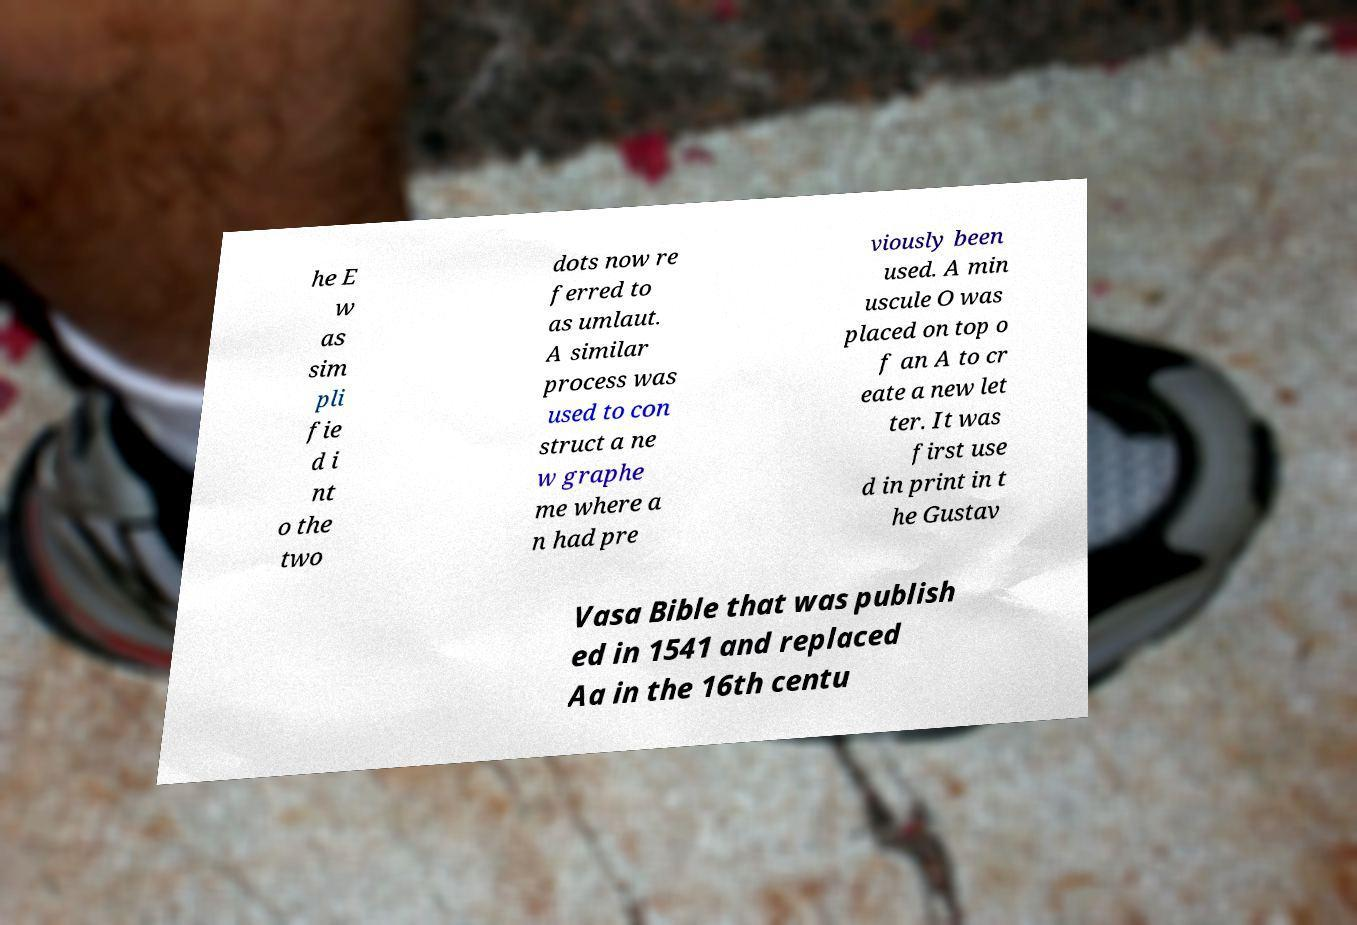Could you extract and type out the text from this image? he E w as sim pli fie d i nt o the two dots now re ferred to as umlaut. A similar process was used to con struct a ne w graphe me where a n had pre viously been used. A min uscule O was placed on top o f an A to cr eate a new let ter. It was first use d in print in t he Gustav Vasa Bible that was publish ed in 1541 and replaced Aa in the 16th centu 